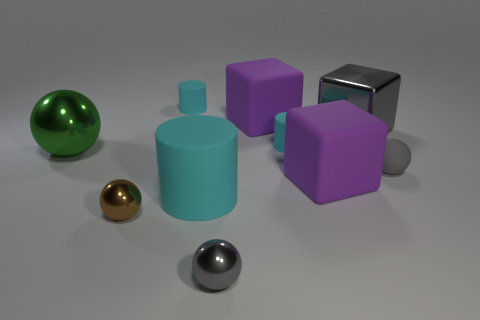Subtract all tiny brown metal balls. How many balls are left? 3 Subtract all yellow cylinders. How many purple cubes are left? 2 Subtract 1 cylinders. How many cylinders are left? 2 Subtract all green spheres. How many spheres are left? 3 Subtract all blocks. How many objects are left? 7 Add 5 big yellow spheres. How many big yellow spheres exist? 5 Subtract 0 gray cylinders. How many objects are left? 10 Subtract all red balls. Subtract all purple cylinders. How many balls are left? 4 Subtract all cyan rubber things. Subtract all green spheres. How many objects are left? 6 Add 3 large green shiny things. How many large green shiny things are left? 4 